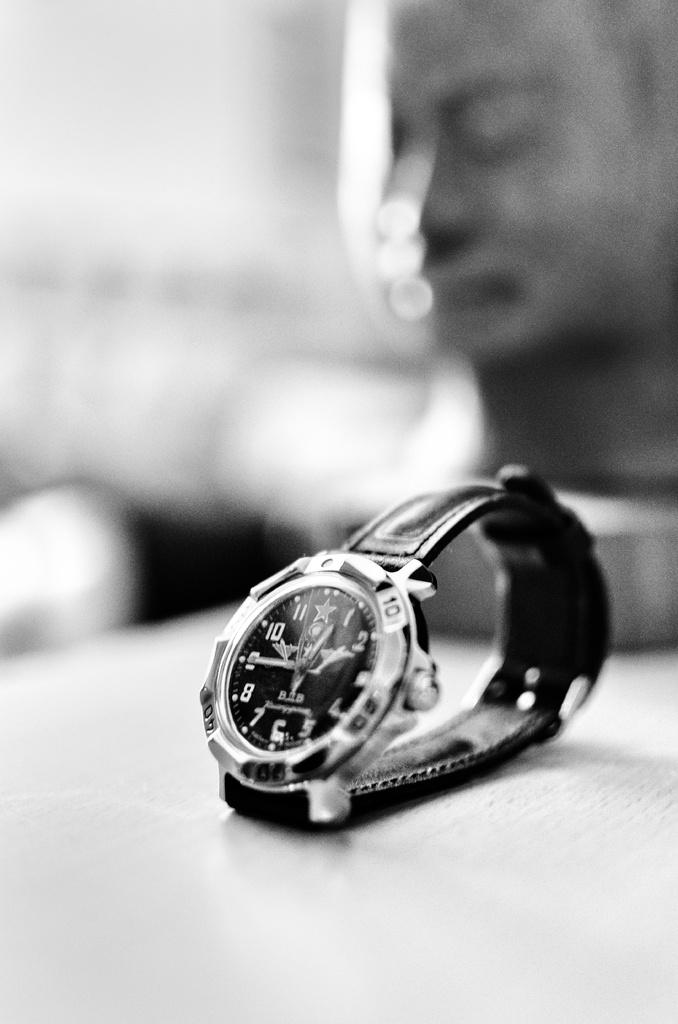Is it nearly 12:45 on this watch?
Keep it short and to the point. Yes. Whatsthe time on the watch?
Your response must be concise. 12:45. 